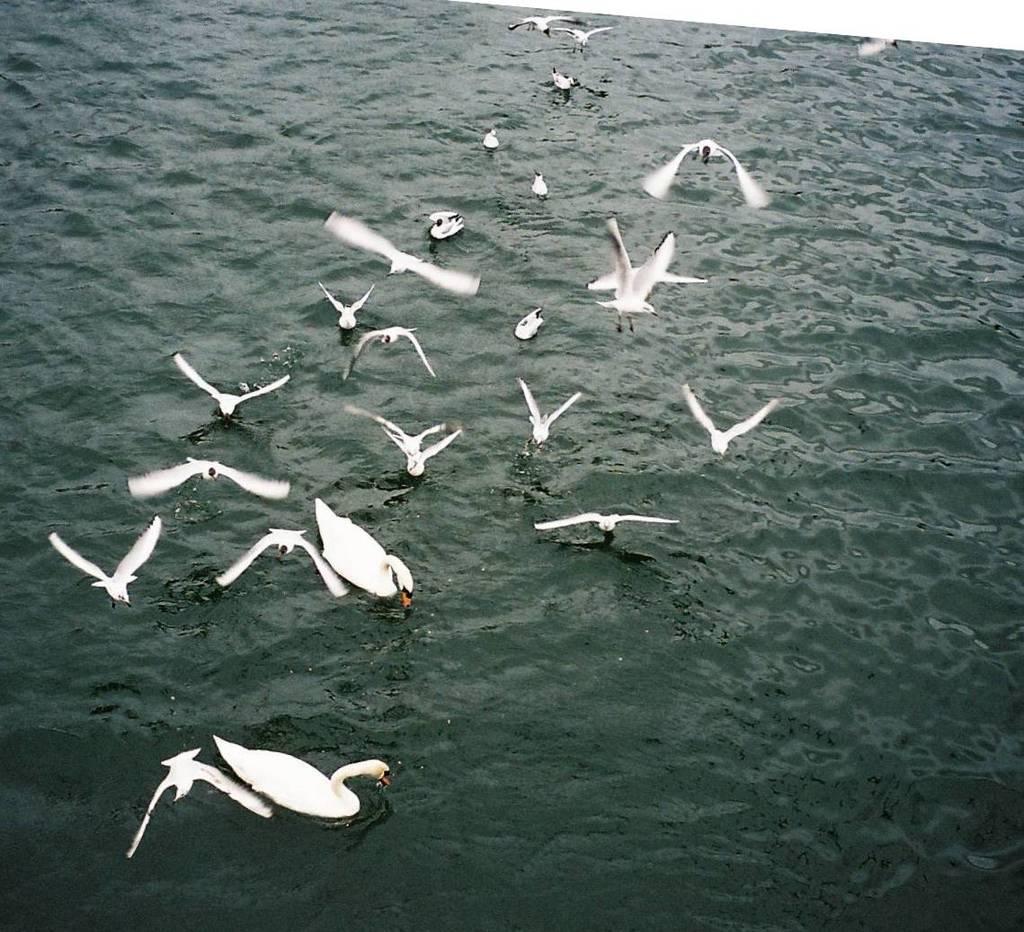In one or two sentences, can you explain what this image depicts? In this picture we can see many ducks and birds on the water. Some birds are flying in the air. 